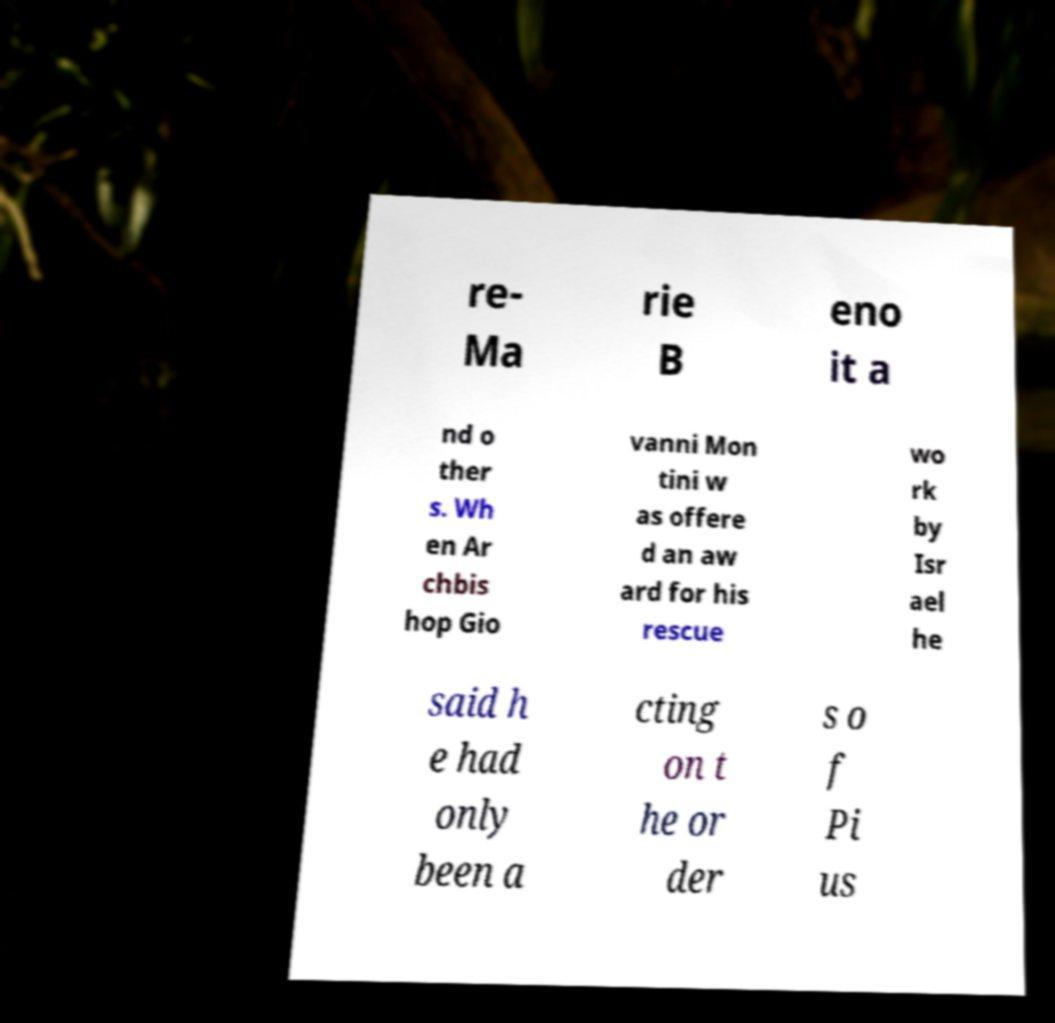What messages or text are displayed in this image? I need them in a readable, typed format. re- Ma rie B eno it a nd o ther s. Wh en Ar chbis hop Gio vanni Mon tini w as offere d an aw ard for his rescue wo rk by Isr ael he said h e had only been a cting on t he or der s o f Pi us 